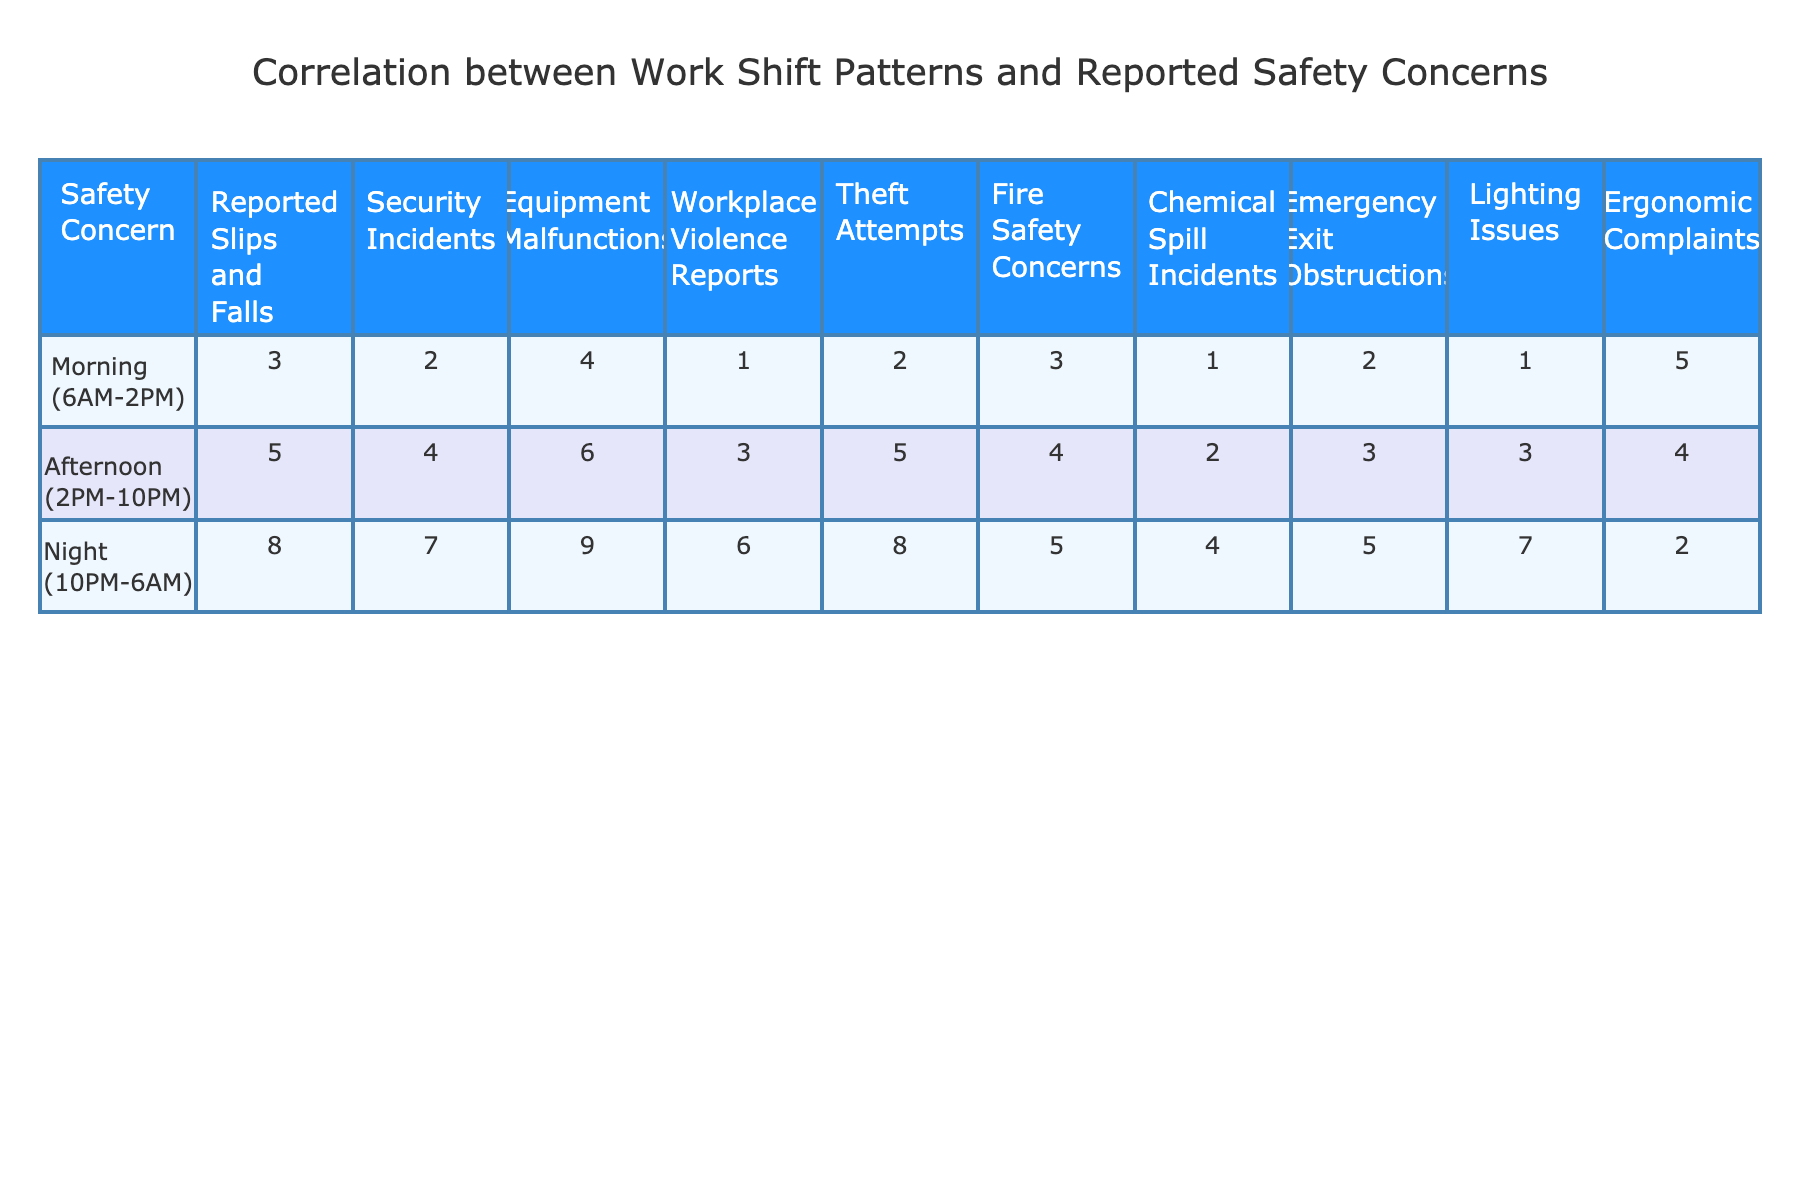What is the highest number of reported slips and falls? The highest number of reported slips and falls is found in the Night shift column which has a value of 8.
Answer: 8 Which shift pattern has the least number of workplace violence reports? By comparing values across the three shift patterns, the Morning shift has the least number of workplace violence reports, with a value of 1.
Answer: Morning What is the total number of security incidents reported across all shifts? To find the total, I add the reported incidents for each shift: 2 (Morning) + 4 (Afternoon) + 7 (Night) = 13.
Answer: 13 Which shift pattern has the most equipment malfunctions reported? The Night shift has the highest reported equipment malfunctions at 9.
Answer: Night What is the average number of theft attempts reported during all shifts? Adding the theft attempts for all shifts gives 2 + 5 + 8 = 15. This total is then divided by the number of shifts (3), resulting in an average of 15 / 3 = 5.
Answer: 5 Is there a higher number of fire safety concerns reported during the Afternoon shift compared to the Morning shift? The Afternoon shift has 4 fire safety concerns while the Morning shift has 3; thus, the statement is true since 4 > 3.
Answer: Yes Which two shift patterns have the closest number of ergonomic complaints reported? The values for ergonomic complaints are 5 (Morning), 4 (Afternoon), and 2 (Night). The closest values are 5 (Morning) and 4 (Afternoon).
Answer: Morning and Afternoon What is the difference in the number of emergency exit obstructions between the Night shift and the Morning shift? The Morning shift has 2 emergency exit obstructions and the Night shift has 5; the difference is calculated as 5 - 2 = 3.
Answer: 3 Which safety concern has the highest reported incidents in the Morning shift? By examining the Morning shift, the highest reported safety concern is ergonomic complaints with a value of 5.
Answer: Ergonomic Complaints If the Night shift's slips and falls incidents were reduced by 3, what would the new total be? The Night shift currently reports 8 slips and falls; reducing this by 3 results in 8 - 3 = 5.
Answer: 5 